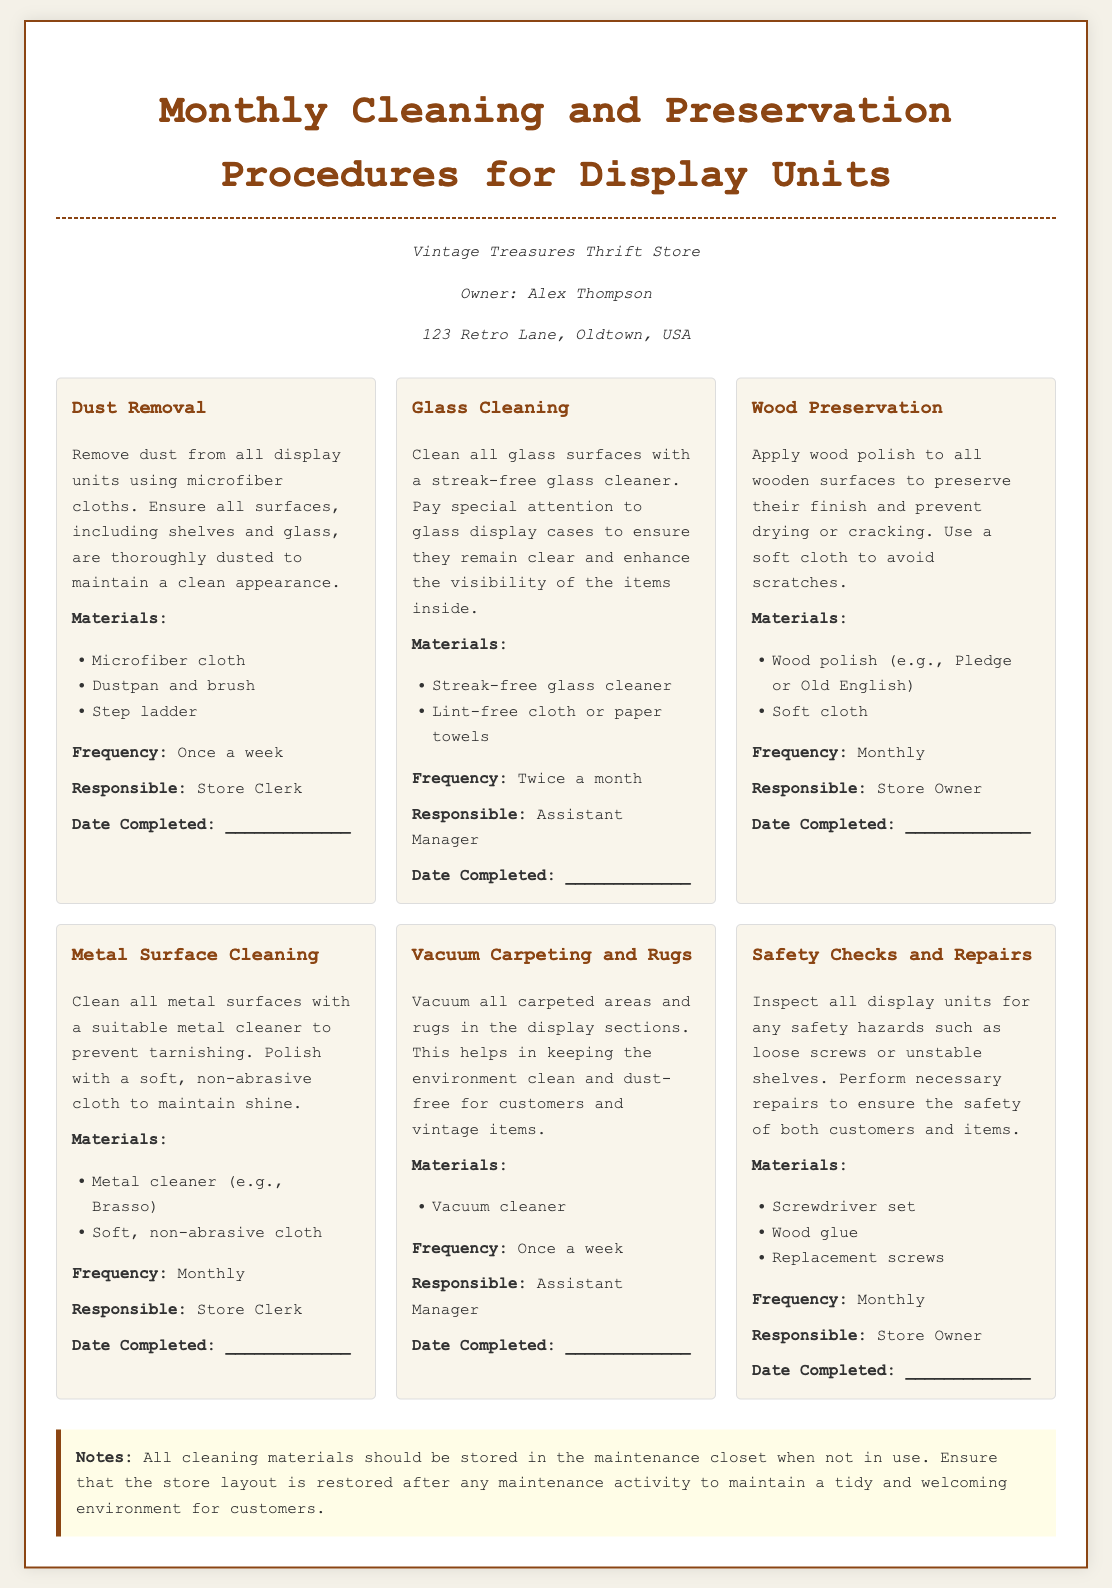What is the title of the document? The title of the document is presented at the top of the page and indicates the content related to maintaining display units.
Answer: Monthly Cleaning and Preservation Procedures for Display Units Who is responsible for wood preservation? The document specifies which individual is responsible for each cleaning and preservation task.
Answer: Store Owner How often should glass cleaning be performed? The frequency of each cleaning task is mentioned in the document, providing a clear guideline for maintenance.
Answer: Twice a month What materials are needed for dust removal? Each task includes a list of necessary materials for completion, which helps ensure thorough cleaning.
Answer: Microfiber cloth, Dustpan and brush, Step ladder What is the purpose of the safety checks? The document describes the task and rationale behind each maintenance procedure, illuminating the importance of safety in the store.
Answer: To ensure the safety of both customers and items When should the carpeting and rugs be vacuumed? The frequency of vacuuming is stated clearly, guiding the cleaning schedule effectively.
Answer: Once a week Which cleaner should be used on metal surfaces? Each cleaning task lists specific products to use, ensuring optimal results for maintenance activities.
Answer: Brasso What should be done with cleaning materials when not in use? The notes section of the document provides additional instructions to maintain an organized environment for staff and customers.
Answer: Stored in the maintenance closet 